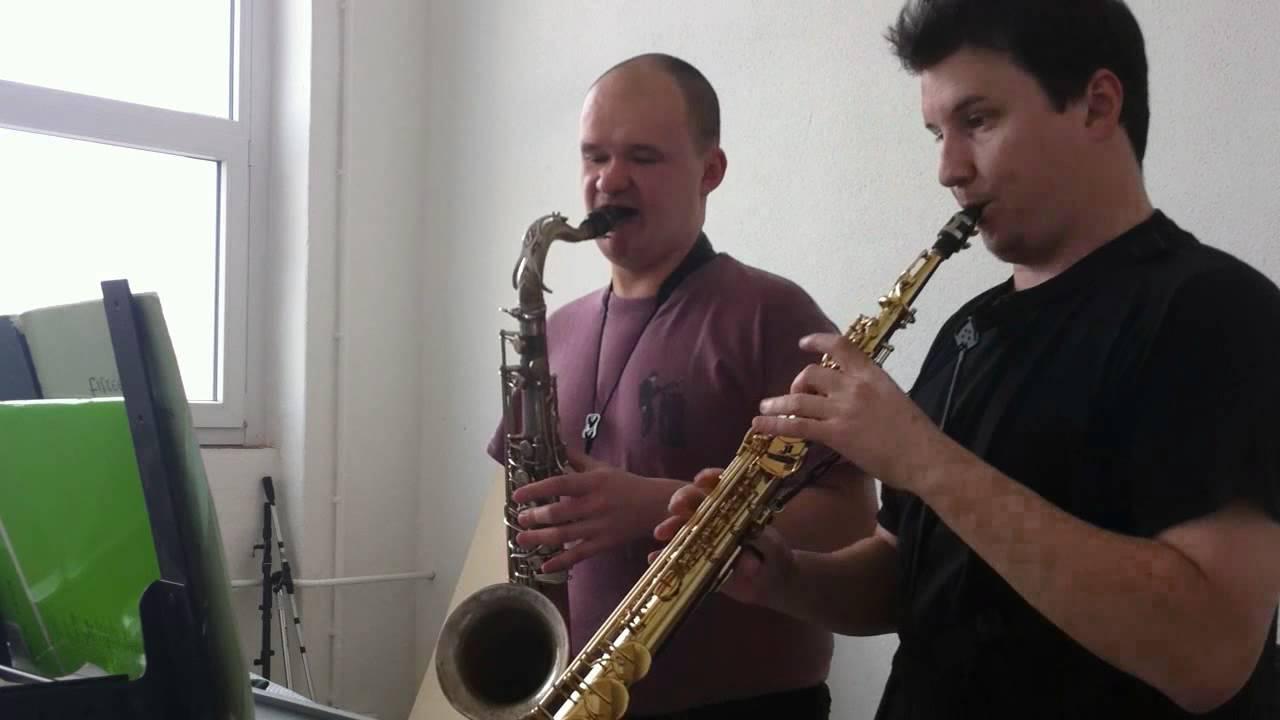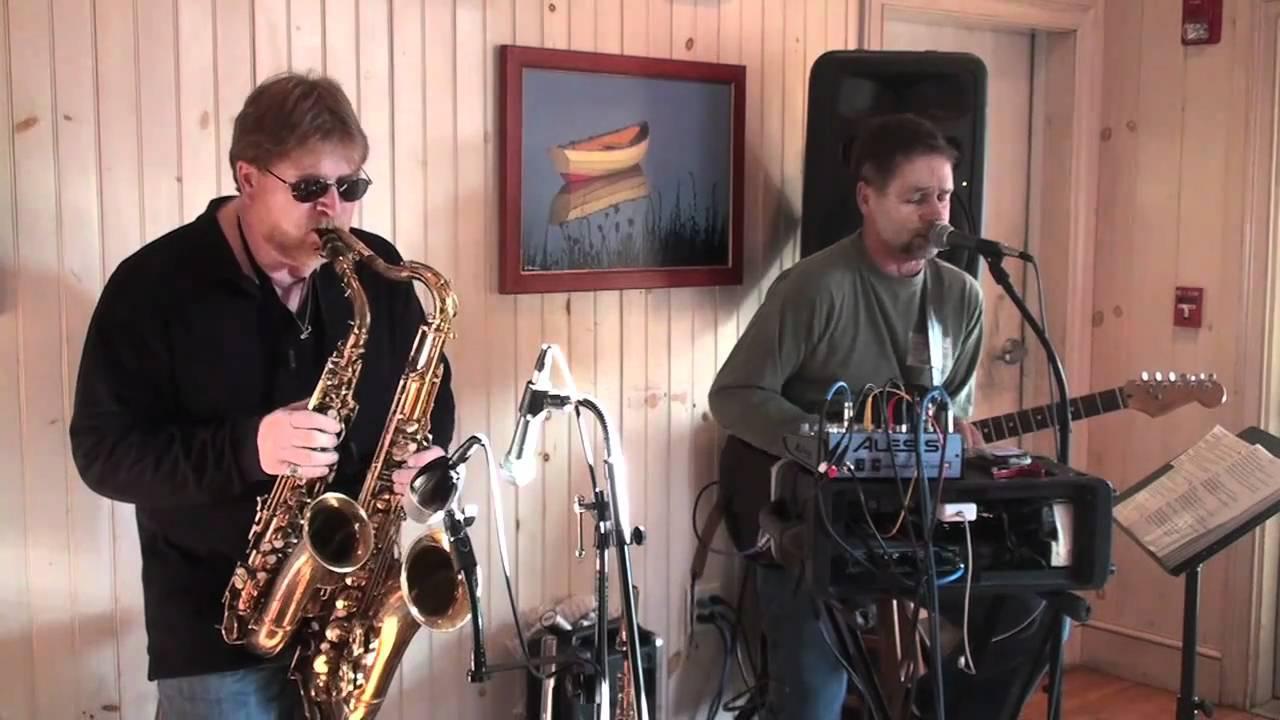The first image is the image on the left, the second image is the image on the right. For the images displayed, is the sentence "Two men, each playing at least two saxophones simultaneously, are the sole people playing musical instruments in the images." factually correct? Answer yes or no. No. The first image is the image on the left, the second image is the image on the right. Given the left and right images, does the statement "A man in a dark hat and dark glasses is playing two saxophones simultaneously." hold true? Answer yes or no. No. The first image is the image on the left, the second image is the image on the right. Examine the images to the left and right. Is the description "The right image contains a man in dark sunglasses holding two saxophones." accurate? Answer yes or no. Yes. The first image is the image on the left, the second image is the image on the right. Considering the images on both sides, is "Two men are in front of microphones, one playing two saxophones and one playing three, with no other persons seen playing any instruments." valid? Answer yes or no. No. 